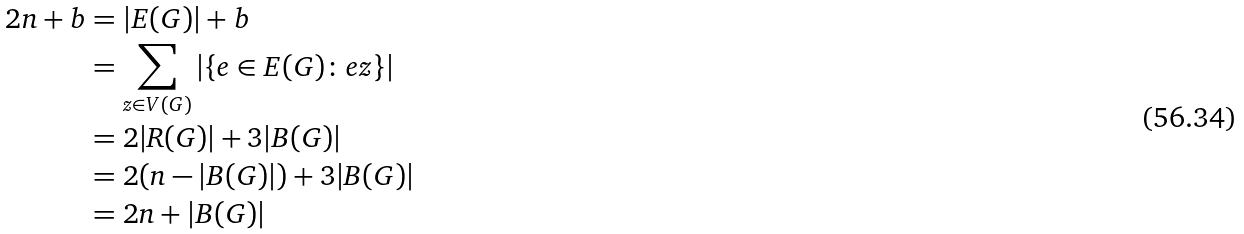Convert formula to latex. <formula><loc_0><loc_0><loc_500><loc_500>2 n + b & = | E ( G ) | + b \\ & = \sum _ { z \in V ( G ) } | \{ e \in E ( G ) \colon e z \} | \\ & = 2 | R ( G ) | + 3 | B ( G ) | \\ & = 2 ( n - | B ( G ) | ) + 3 | B ( G ) | \\ & = 2 n + | B ( G ) | \\</formula> 